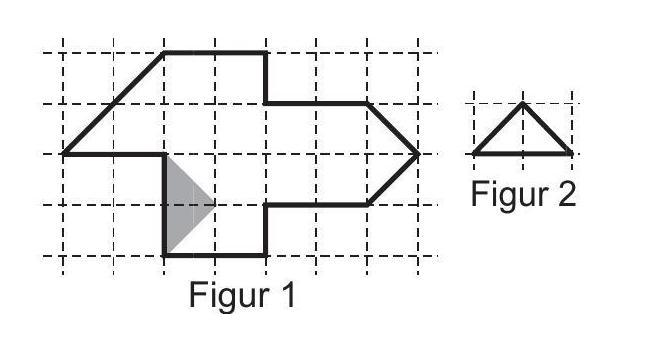Luca wants to cut the shape in figure 1 into equally sized small triangles (like those in figure 2). One of these triangles is already drawn on figure 1. How many of these triangles will he get? Luca can cut Figure 1 into 15 equal triangles similar to the one shown in Figure 2. Each triangle fits perfectly within the larger shape, ensuring all sections are utilized efficiently with no leftover areas. 